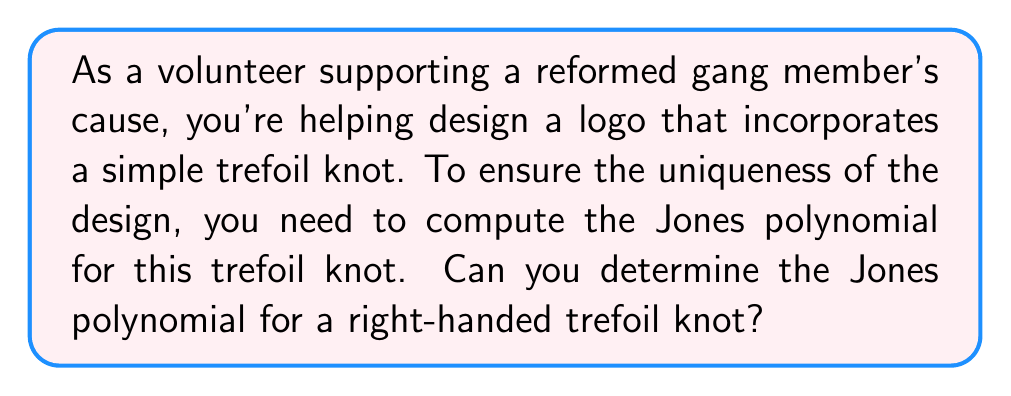Can you answer this question? Let's compute the Jones polynomial for a right-handed trefoil knot step by step:

1) First, we need to create a diagram of the right-handed trefoil knot:

[asy]
import geometry;

path p = (0,0){dir(60)}..{dir(-60)}(1,0){dir(60)}..{dir(-60)}(-1,0){dir(60)}..{dir(-60)}cycle;
draw(p,linewidth(1));
draw(p,linewidth(3)+white);
draw(p,linewidth(1));

dot((0.5,0.866),red);
dot((-0.5,0.866),red);
dot((0,-0.866),red);
[/asy]

2) We'll use the Kauffman bracket method to compute the Jones polynomial. The Kauffman bracket is related to the Jones polynomial by a simple transformation.

3) For each crossing in the trefoil knot, we have two possible resolutions:
   $A$ resolution: $\langle\quad\rangle$ and $B$ resolution: $\rangle\quad\langle$

4) The Kauffman bracket is calculated as:
   $\langle K \rangle = A\langle K_A \rangle + A^{-1}\langle K_B \rangle$

5) For the trefoil knot, we have three crossings. Resolving all of them gives:

   $\langle trefoil \rangle = A^3\langle \bigcirc \bigcirc \rangle + 3A\langle \bigcirc \rangle + 3A^{-1}\langle \bigcirc \rangle + A^{-3}\langle \bigcirc \bigcirc \rangle$

6) We use these rules:
   $\langle \bigcirc \rangle = -A^2 - A^{-2}$
   $\langle \bigcirc \bigcirc \rangle = (-A^2 - A^{-2})^2$

7) Substituting:
   $\langle trefoil \rangle = A^3(-A^2 - A^{-2})^2 + 3A(-A^2 - A^{-2}) + 3A^{-1}(-A^2 - A^{-2}) + A^{-3}(-A^2 - A^{-2})^2$

8) Simplifying:
   $\langle trefoil \rangle = A^7 + A^3 + A^{-1}$

9) To get the Jones polynomial, we use the formula:
   $V_K(t) = ((-A)^{-3w(K)})\langle K \rangle|_{A = t^{-1/4}}$

   where $w(K)$ is the writhe of the knot. For a right-handed trefoil, $w(K) = 3$.

10) Substituting:
    $V_K(t) = ((-t^{-1/4})^{-9})(t^{-7/4} + t^{-3/4} + t^{1/4})$

11) Simplifying:
    $V_K(t) = t + t^3 - t^4$

This is the Jones polynomial for a right-handed trefoil knot.
Answer: $t + t^3 - t^4$ 